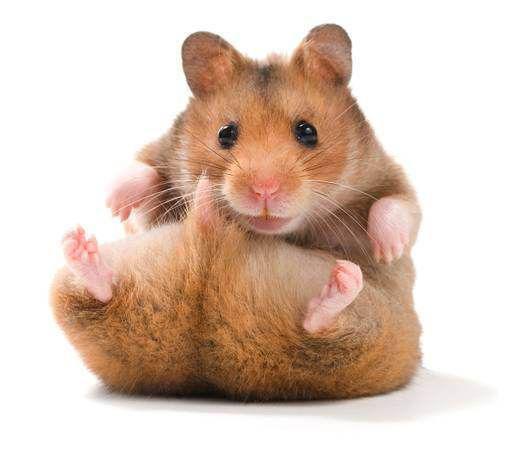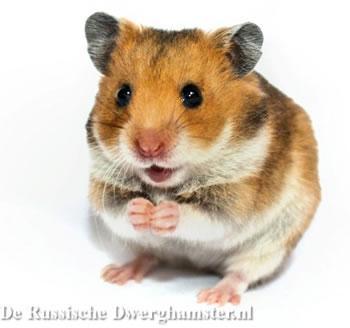The first image is the image on the left, the second image is the image on the right. Assess this claim about the two images: "The single hamster in one of the images has three feet on the floor and the other raised.". Correct or not? Answer yes or no. No. 